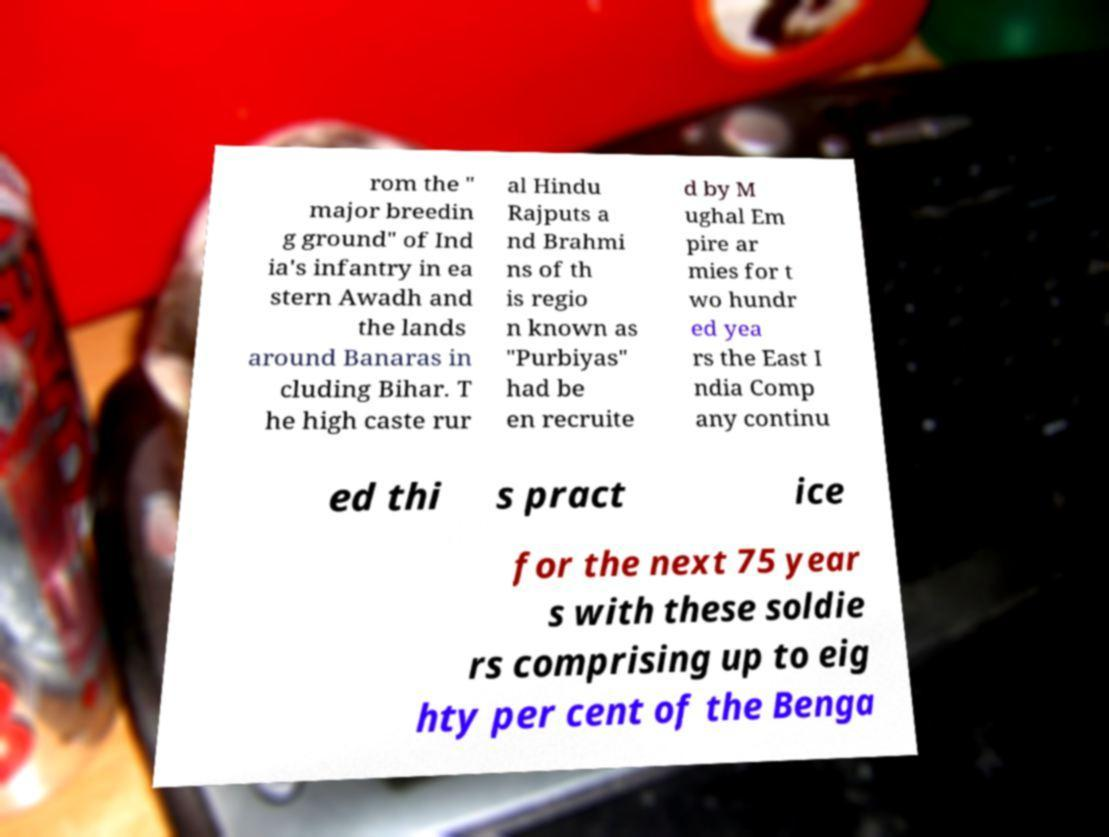What messages or text are displayed in this image? I need them in a readable, typed format. rom the " major breedin g ground" of Ind ia's infantry in ea stern Awadh and the lands around Banaras in cluding Bihar. T he high caste rur al Hindu Rajputs a nd Brahmi ns of th is regio n known as "Purbiyas" had be en recruite d by M ughal Em pire ar mies for t wo hundr ed yea rs the East I ndia Comp any continu ed thi s pract ice for the next 75 year s with these soldie rs comprising up to eig hty per cent of the Benga 